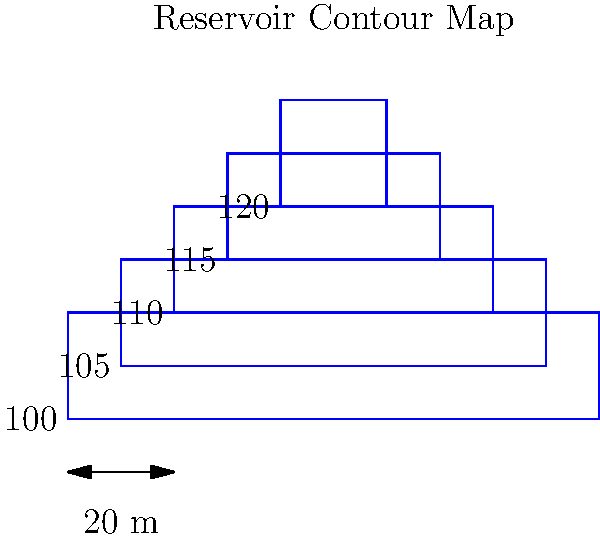In the spirit of ABBA's "Gimme! Gimme! Gimme! (A Man After Midnight)," imagine you're working on a midnight water project. Using the contour map of a reservoir shown above, with contour intervals of 5 meters, estimate the volume of water in the reservoir when it's filled to the 115-meter level. How many cubic meters of refreshing water could potentially inspire your next hit song? Let's break this down step-by-step, like composing a catchy pop tune:

1) First, we need to identify the contour areas:
   - 100 m: $A_1 = 100 \times 20 = 2000 \text{ m}^2$
   - 105 m: $A_2 = 80 \times 20 = 1600 \text{ m}^2$
   - 110 m: $A_3 = 60 \times 20 = 1200 \text{ m}^2$
   - 115 m: $A_4 = 40 \times 20 = 800 \text{ m}^2$

2) Now, we'll use the prismoidal formula to calculate the volume:
   $V = \frac{h}{3}(A_1 + A_n + 4M)$
   Where $h$ is the height between contours, $A_1$ is the area of the lower contour, $A_n$ is the area of the upper contour, and $M$ is the area of the middle contour.

3) We have three 5-meter sections to calculate:

   100 m to 105 m:
   $V_1 = \frac{5}{3}(2000 + 1600 + 4 \times 1800) = 15000 \text{ m}^3$

   105 m to 110 m:
   $V_2 = \frac{5}{3}(1600 + 1200 + 4 \times 1400) = 11667 \text{ m}^3$

   110 m to 115 m:
   $V_3 = \frac{5}{3}(1200 + 800 + 4 \times 1000) = 8333 \text{ m}^3$

4) The total volume is the sum of these three sections:
   $V_{total} = V_1 + V_2 + V_3 = 15000 + 11667 + 8333 = 35000 \text{ m}^3$

Thus, the reservoir contains approximately 35,000 cubic meters of water when filled to the 115-meter level.
Answer: 35,000 $\text{m}^3$ 